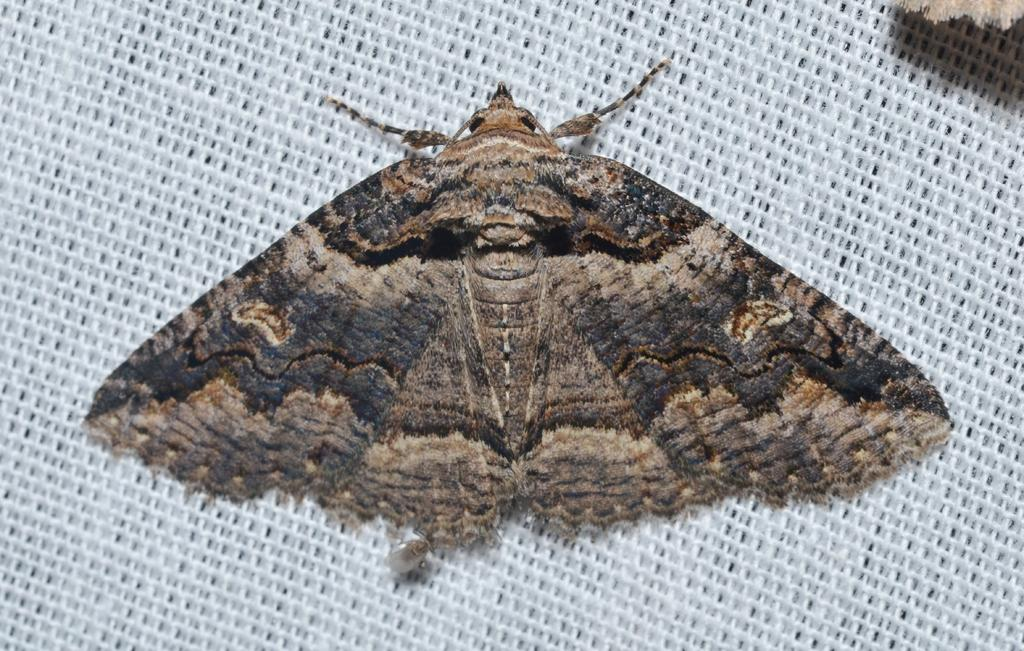What is the main subject of the image? The main subject of the image is a butterfly. What is the butterfly resting on in the image? The butterfly is laying on a white net surface. What is the reason for the butterfly's presence on the stage in the image? There is no stage present in the image, and the butterfly is not performing or participating in any event. 